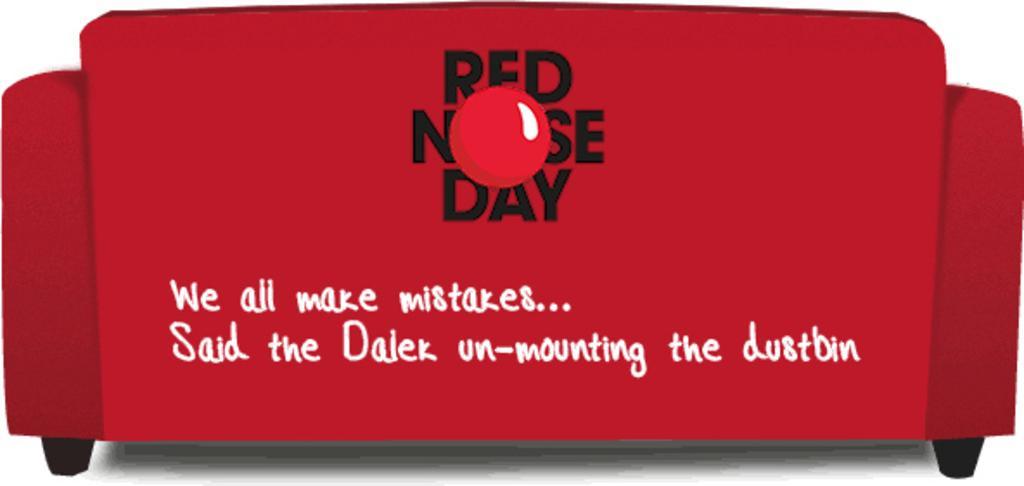In one or two sentences, can you explain what this image depicts? In this image, we can see a couch which is in red color with some text written on it. 